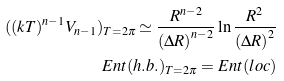<formula> <loc_0><loc_0><loc_500><loc_500>( ( k T ) ^ { n - 1 } V _ { n - 1 } ) _ { T = 2 \pi } \simeq \frac { R ^ { n - 2 } } { \left ( \Delta R \right ) ^ { n - 2 } } \ln \frac { R ^ { 2 } } { \left ( \Delta R \right ) ^ { 2 } } & \\ E n t ( h . b . ) _ { T = 2 \pi } = E n t ( l o c ) &</formula> 